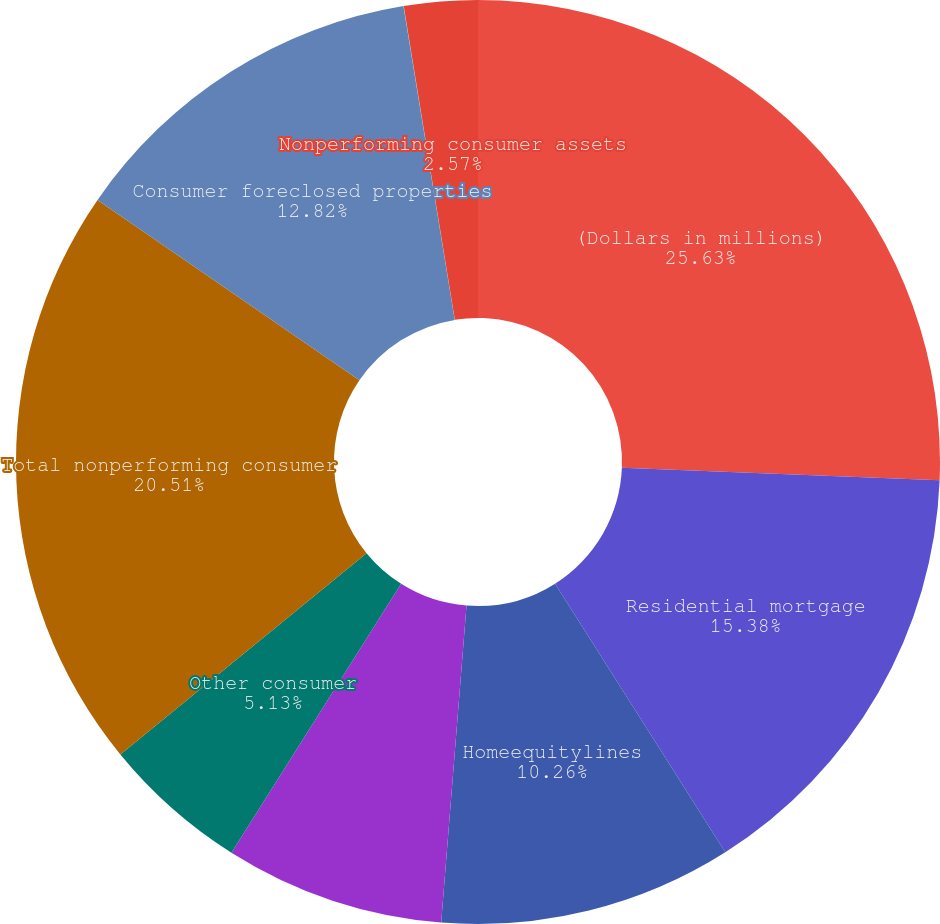Convert chart. <chart><loc_0><loc_0><loc_500><loc_500><pie_chart><fcel>(Dollars in millions)<fcel>Residential mortgage<fcel>Homeequitylines<fcel>Direct/Indirect consumer<fcel>Other consumer<fcel>Total nonperforming consumer<fcel>Consumer foreclosed properties<fcel>Nonperforming consumer loans<fcel>Nonperforming consumer assets<nl><fcel>25.63%<fcel>15.38%<fcel>10.26%<fcel>7.69%<fcel>5.13%<fcel>20.51%<fcel>12.82%<fcel>0.01%<fcel>2.57%<nl></chart> 